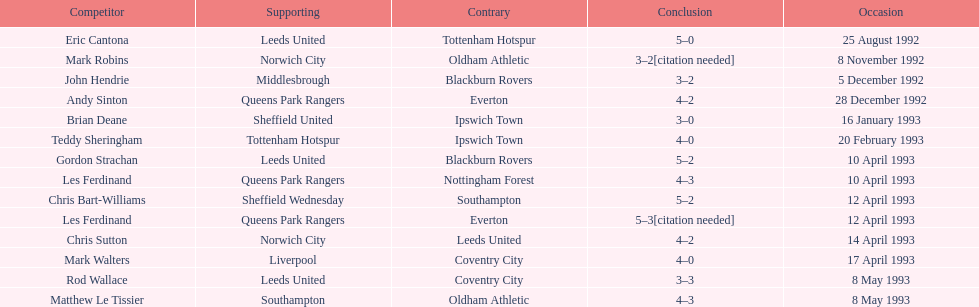What was the result of the match between queens park rangers and everton? 4-2. Would you mind parsing the complete table? {'header': ['Competitor', 'Supporting', 'Contrary', 'Conclusion', 'Occasion'], 'rows': [['Eric Cantona', 'Leeds United', 'Tottenham Hotspur', '5–0', '25 August 1992'], ['Mark Robins', 'Norwich City', 'Oldham Athletic', '3–2[citation needed]', '8 November 1992'], ['John Hendrie', 'Middlesbrough', 'Blackburn Rovers', '3–2', '5 December 1992'], ['Andy Sinton', 'Queens Park Rangers', 'Everton', '4–2', '28 December 1992'], ['Brian Deane', 'Sheffield United', 'Ipswich Town', '3–0', '16 January 1993'], ['Teddy Sheringham', 'Tottenham Hotspur', 'Ipswich Town', '4–0', '20 February 1993'], ['Gordon Strachan', 'Leeds United', 'Blackburn Rovers', '5–2', '10 April 1993'], ['Les Ferdinand', 'Queens Park Rangers', 'Nottingham Forest', '4–3', '10 April 1993'], ['Chris Bart-Williams', 'Sheffield Wednesday', 'Southampton', '5–2', '12 April 1993'], ['Les Ferdinand', 'Queens Park Rangers', 'Everton', '5–3[citation needed]', '12 April 1993'], ['Chris Sutton', 'Norwich City', 'Leeds United', '4–2', '14 April 1993'], ['Mark Walters', 'Liverpool', 'Coventry City', '4–0', '17 April 1993'], ['Rod Wallace', 'Leeds United', 'Coventry City', '3–3', '8 May 1993'], ['Matthew Le Tissier', 'Southampton', 'Oldham Athletic', '4–3', '8 May 1993']]} 